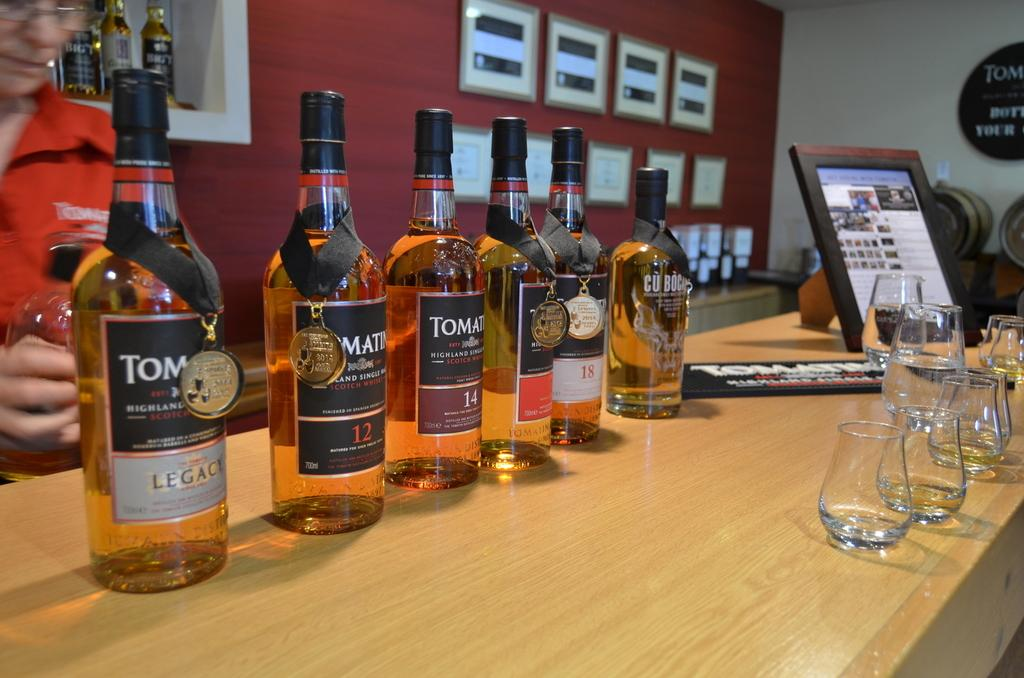<image>
Offer a succinct explanation of the picture presented. six bottles of scotch are lined up on a bar 